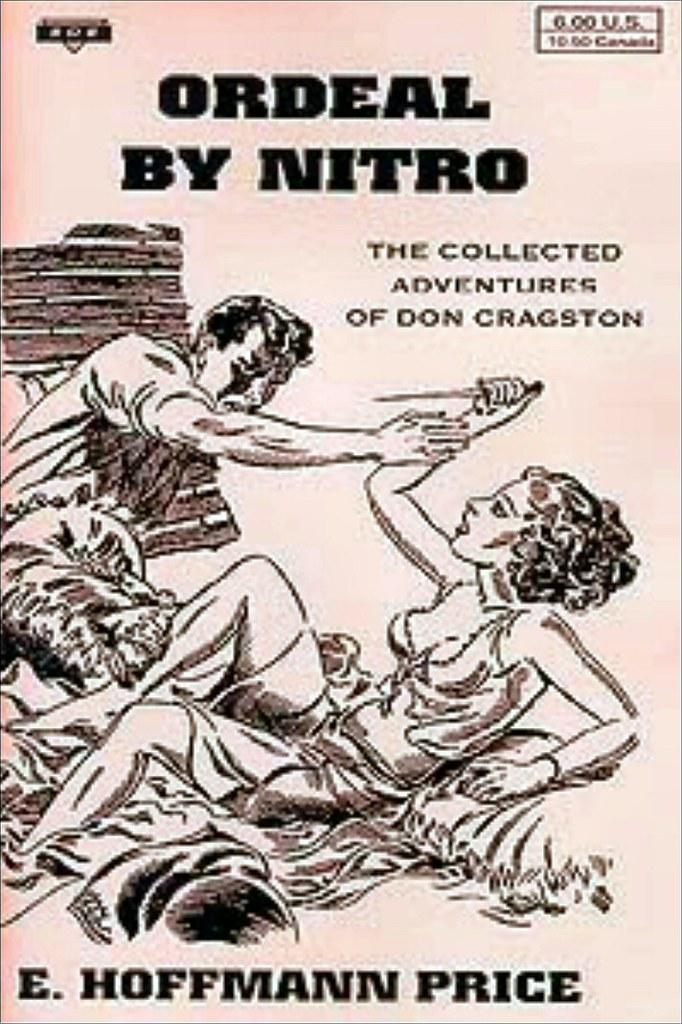What is featured in the picture? There is a poster in the picture. What can be seen in the poster? The poster contains a photo of two persons. What else is present on the poster besides the photo? There are words and numbers on the poster. Is there a sink visible in the image? No, there is no sink present in the image. Can you see a straw in the photo of the two persons? No, there is no straw visible in the image. 